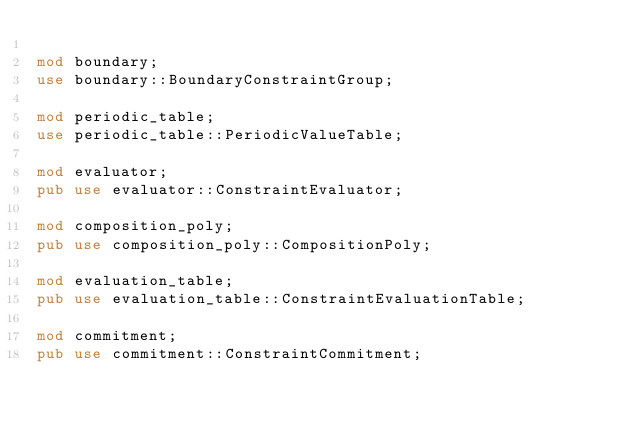<code> <loc_0><loc_0><loc_500><loc_500><_Rust_>
mod boundary;
use boundary::BoundaryConstraintGroup;

mod periodic_table;
use periodic_table::PeriodicValueTable;

mod evaluator;
pub use evaluator::ConstraintEvaluator;

mod composition_poly;
pub use composition_poly::CompositionPoly;

mod evaluation_table;
pub use evaluation_table::ConstraintEvaluationTable;

mod commitment;
pub use commitment::ConstraintCommitment;
</code> 